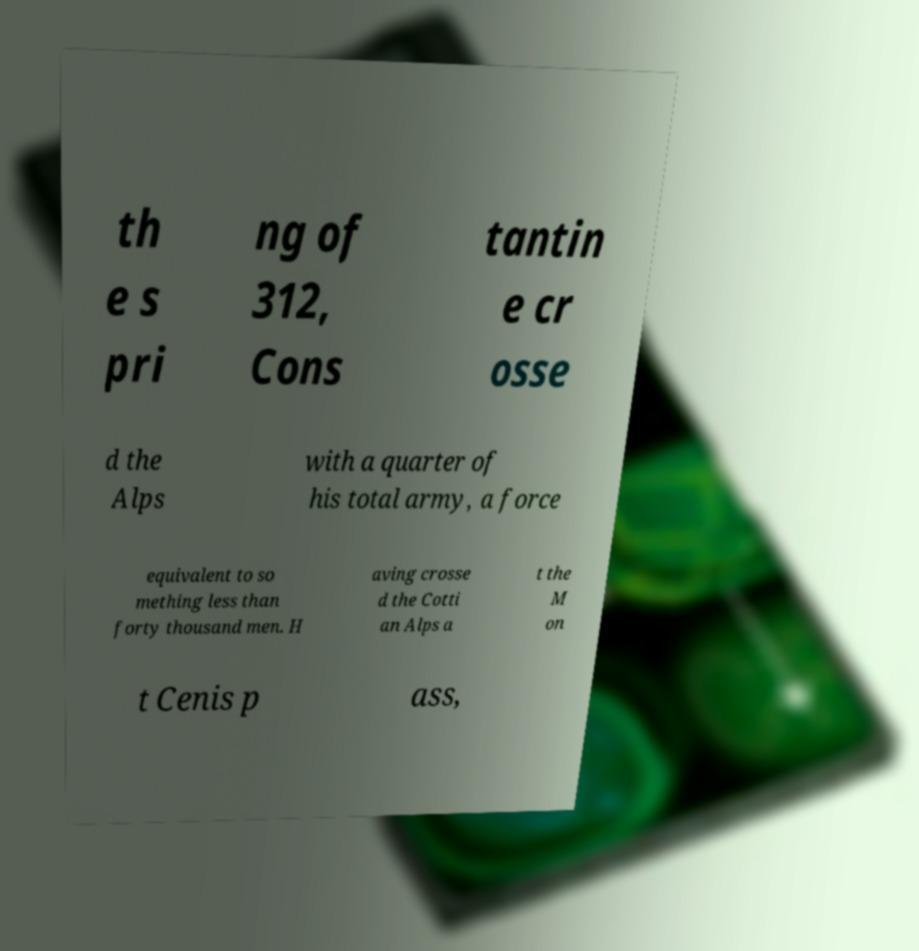Please identify and transcribe the text found in this image. th e s pri ng of 312, Cons tantin e cr osse d the Alps with a quarter of his total army, a force equivalent to so mething less than forty thousand men. H aving crosse d the Cotti an Alps a t the M on t Cenis p ass, 